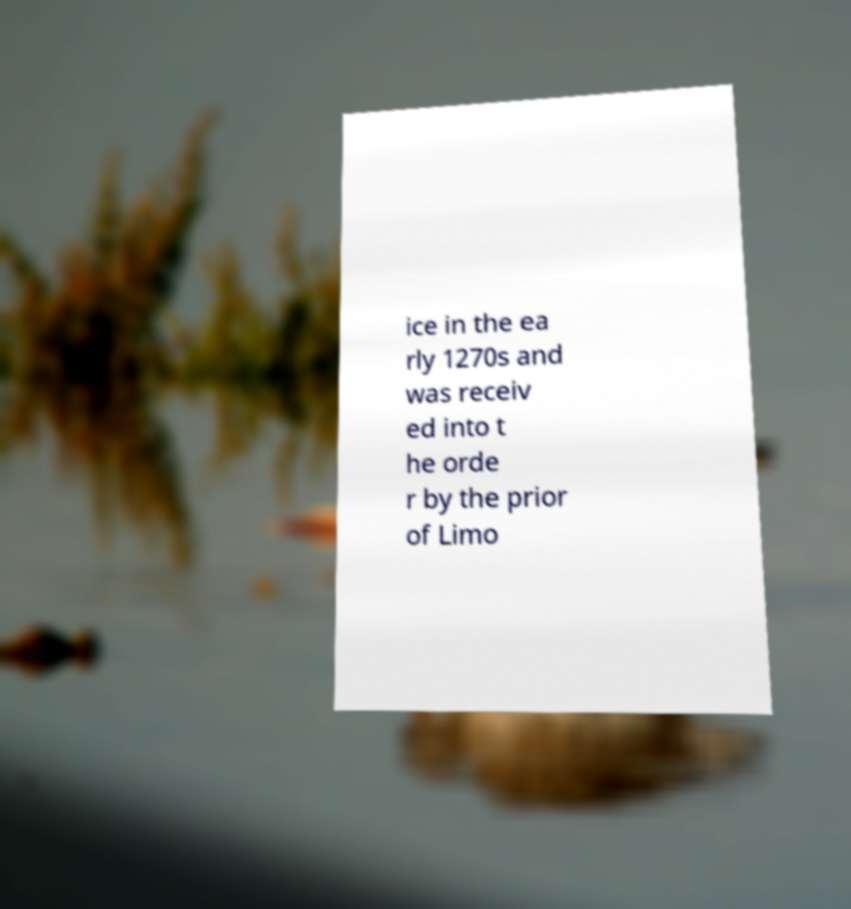Can you read and provide the text displayed in the image?This photo seems to have some interesting text. Can you extract and type it out for me? ice in the ea rly 1270s and was receiv ed into t he orde r by the prior of Limo 